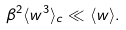Convert formula to latex. <formula><loc_0><loc_0><loc_500><loc_500>\beta ^ { 2 } \langle w ^ { 3 } \rangle _ { c } \ll \langle w \rangle .</formula> 